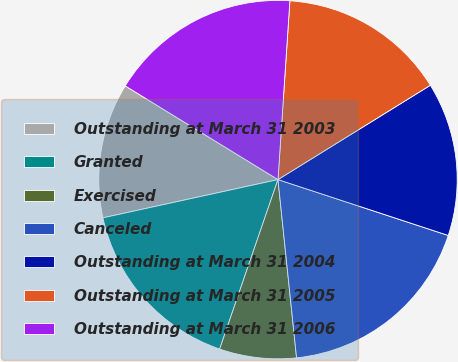Convert chart. <chart><loc_0><loc_0><loc_500><loc_500><pie_chart><fcel>Outstanding at March 31 2003<fcel>Granted<fcel>Exercised<fcel>Canceled<fcel>Outstanding at March 31 2004<fcel>Outstanding at March 31 2005<fcel>Outstanding at March 31 2006<nl><fcel>12.18%<fcel>16.3%<fcel>6.93%<fcel>18.3%<fcel>13.87%<fcel>15.12%<fcel>17.3%<nl></chart> 